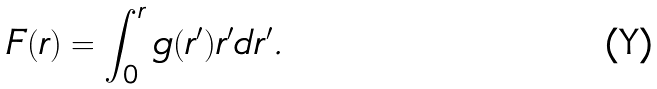<formula> <loc_0><loc_0><loc_500><loc_500>F ( r ) = \int _ { 0 } ^ { r } g ( r ^ { \prime } ) r ^ { \prime } d r ^ { \prime } .</formula> 